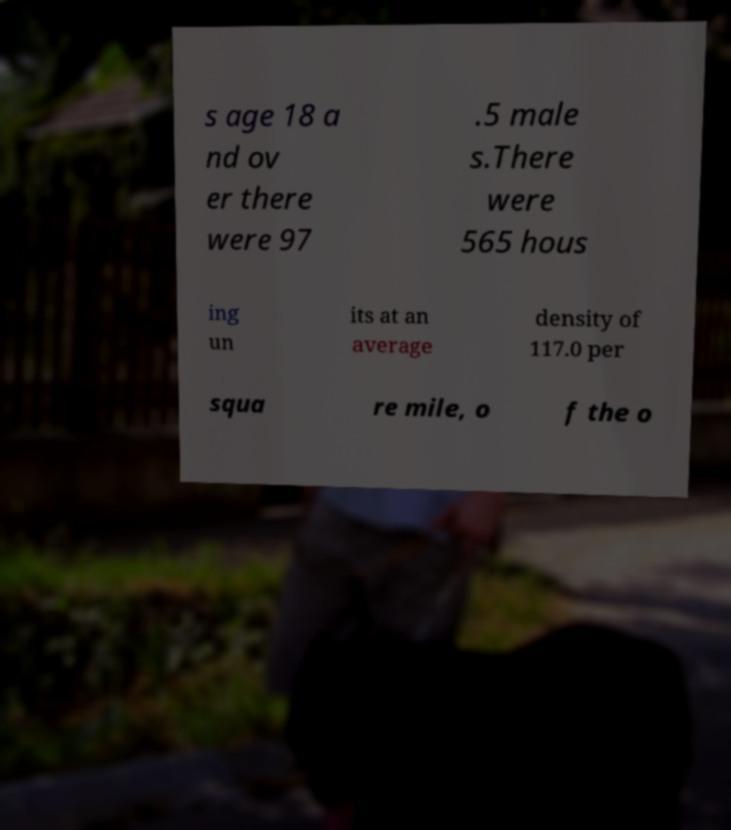Can you read and provide the text displayed in the image?This photo seems to have some interesting text. Can you extract and type it out for me? s age 18 a nd ov er there were 97 .5 male s.There were 565 hous ing un its at an average density of 117.0 per squa re mile, o f the o 